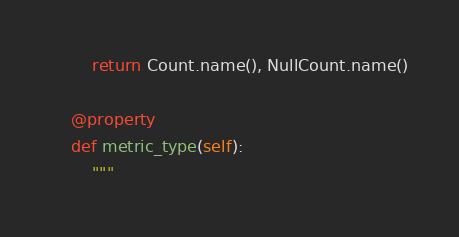<code> <loc_0><loc_0><loc_500><loc_500><_Python_>        return Count.name(), NullCount.name()

    @property
    def metric_type(self):
        """</code> 